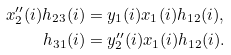Convert formula to latex. <formula><loc_0><loc_0><loc_500><loc_500>x _ { 2 } ^ { \prime \prime } ( i ) h _ { 2 3 } ( i ) & = y _ { 1 } ( i ) x _ { 1 } ( i ) h _ { 1 2 } ( i ) , \\ h _ { 3 1 } ( i ) & = y _ { 2 } ^ { \prime \prime } ( i ) x _ { 1 } ( i ) h _ { 1 2 } ( i ) .</formula> 